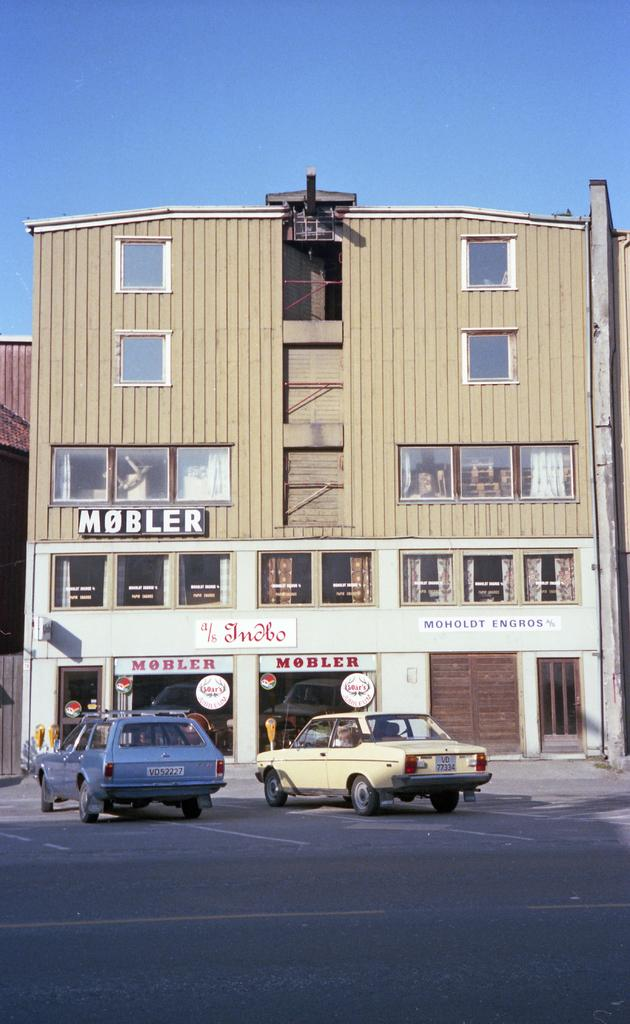What can be seen on the road in the image? There are cars on the road in the image. What is visible in the background of the image? There are buildings in the background of the image. Can you describe any specific details about the buildings? There is some text written on a building in the image. Can you tell me what type of prose is being read by the deer in the image? There are no deer present in the image, and therefore no prose can be read by them. 